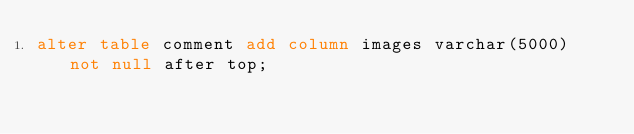<code> <loc_0><loc_0><loc_500><loc_500><_SQL_>alter table comment add column images varchar(5000) not null after top;</code> 